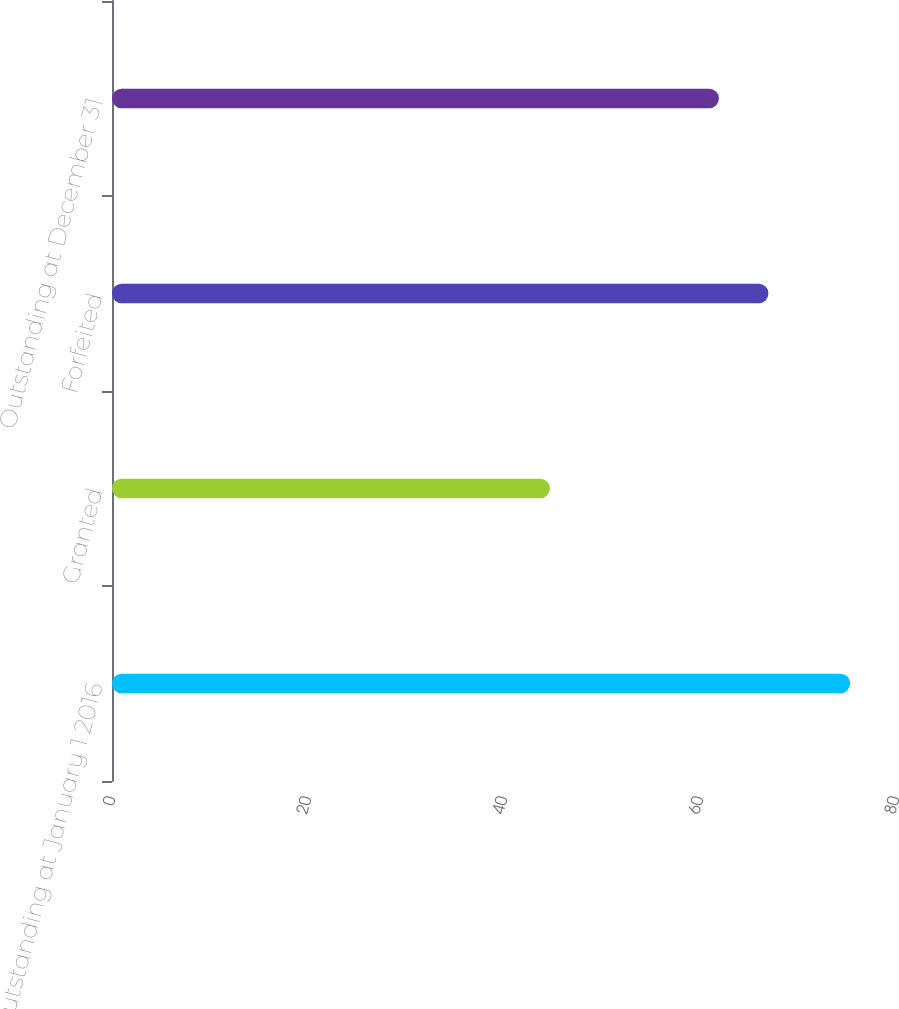Convert chart. <chart><loc_0><loc_0><loc_500><loc_500><bar_chart><fcel>Outstanding at January 1 2016<fcel>Granted<fcel>Forfeited<fcel>Outstanding at December 31<nl><fcel>75.32<fcel>44.69<fcel>66.98<fcel>61.93<nl></chart> 